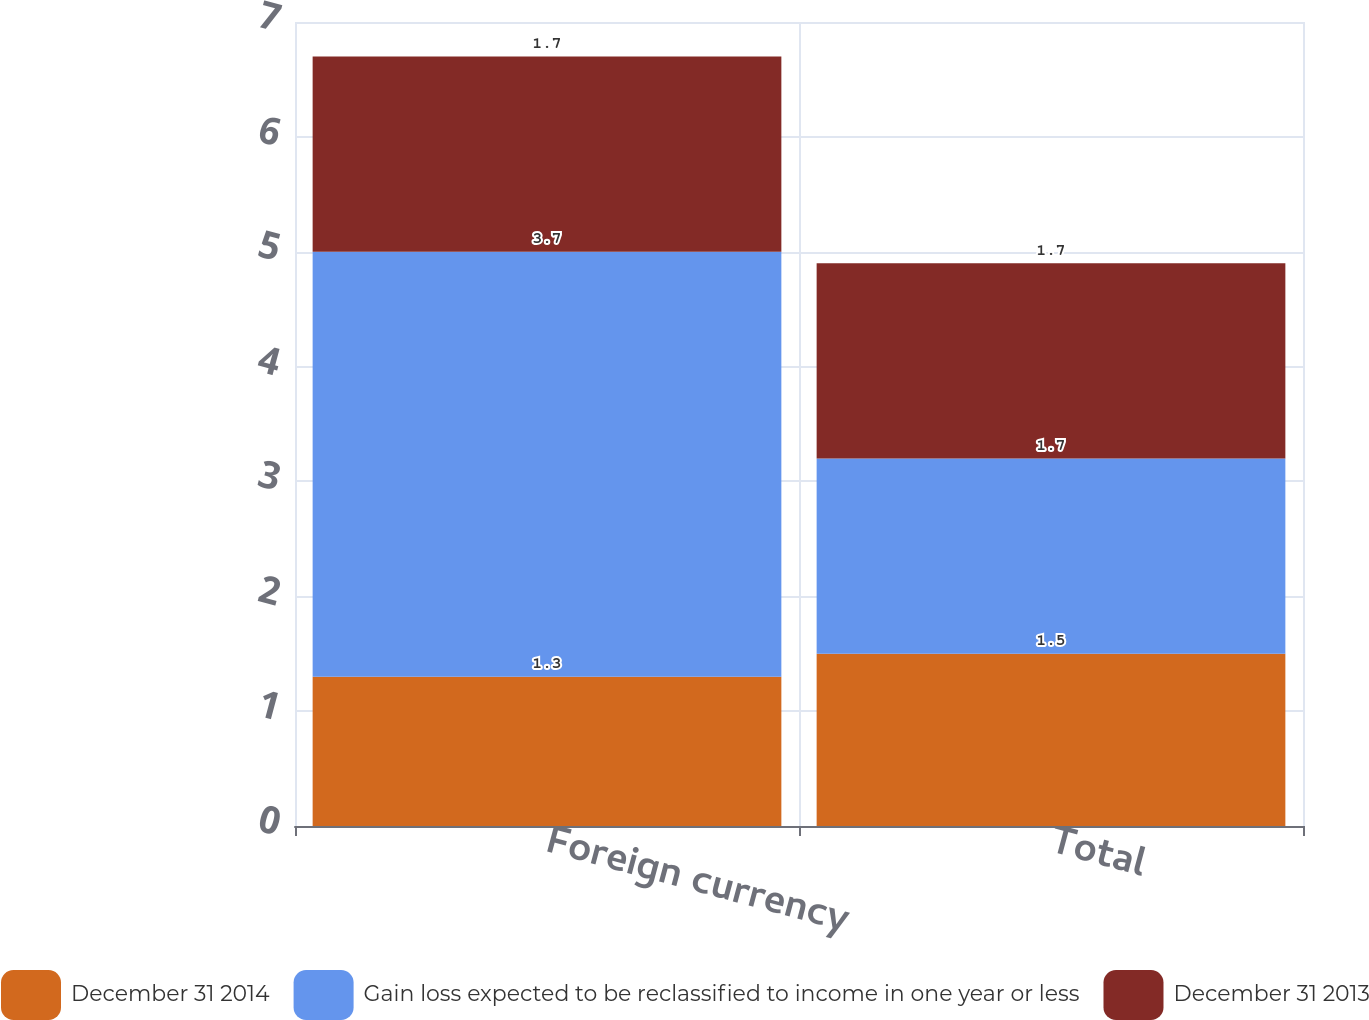Convert chart. <chart><loc_0><loc_0><loc_500><loc_500><stacked_bar_chart><ecel><fcel>Foreign currency<fcel>Total<nl><fcel>December 31 2014<fcel>1.3<fcel>1.5<nl><fcel>Gain loss expected to be reclassified to income in one year or less<fcel>3.7<fcel>1.7<nl><fcel>December 31 2013<fcel>1.7<fcel>1.7<nl></chart> 